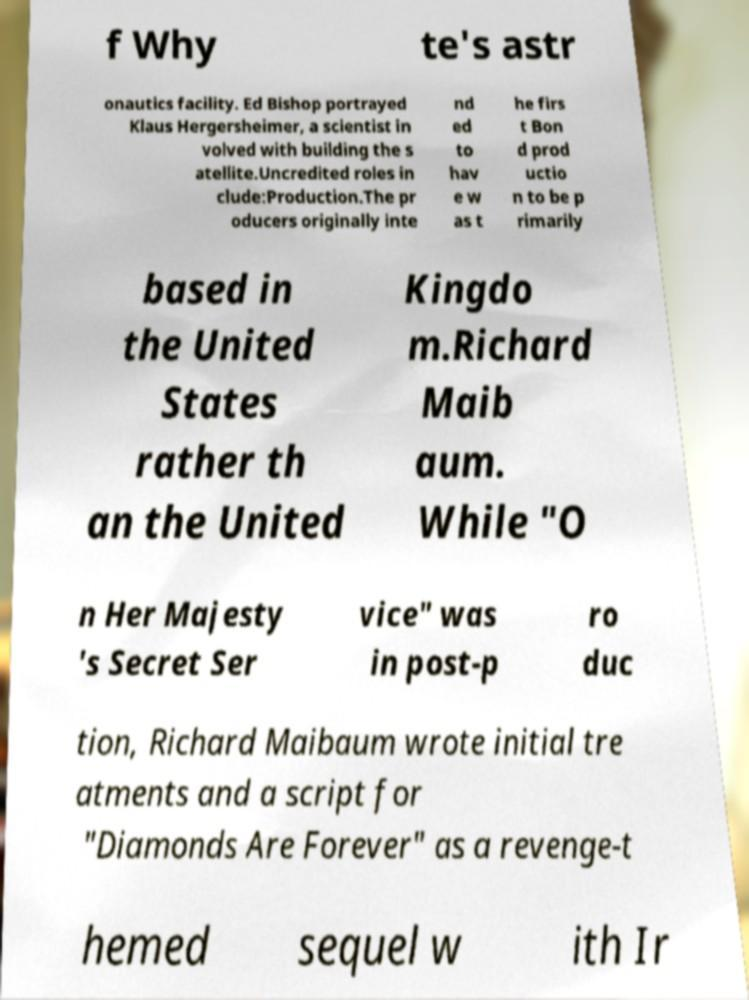I need the written content from this picture converted into text. Can you do that? f Why te's astr onautics facility. Ed Bishop portrayed Klaus Hergersheimer, a scientist in volved with building the s atellite.Uncredited roles in clude:Production.The pr oducers originally inte nd ed to hav e w as t he firs t Bon d prod uctio n to be p rimarily based in the United States rather th an the United Kingdo m.Richard Maib aum. While "O n Her Majesty 's Secret Ser vice" was in post-p ro duc tion, Richard Maibaum wrote initial tre atments and a script for "Diamonds Are Forever" as a revenge-t hemed sequel w ith Ir 